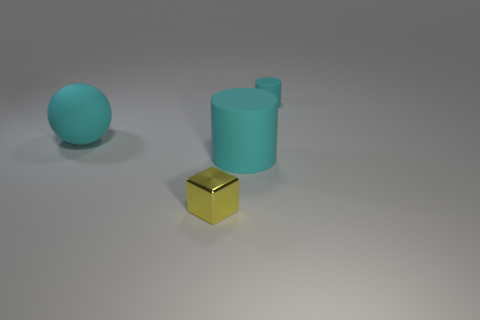Do the shiny thing and the cyan cylinder that is behind the large cyan sphere have the same size?
Your answer should be very brief. Yes. There is a cylinder to the left of the tiny cyan thing; what color is it?
Offer a very short reply. Cyan. What number of yellow things are matte balls or shiny blocks?
Offer a very short reply. 1. What color is the large matte cylinder?
Keep it short and to the point. Cyan. Is there any other thing that is made of the same material as the yellow cube?
Your answer should be very brief. No. Is the number of big things that are in front of the matte ball less than the number of small metal things that are left of the tiny yellow shiny thing?
Offer a very short reply. No. There is a thing that is both behind the large cylinder and right of the small block; what shape is it?
Your answer should be very brief. Cylinder. What number of yellow metal objects are the same shape as the small cyan matte thing?
Your answer should be very brief. 0. There is a ball that is the same material as the small cyan cylinder; what is its size?
Your response must be concise. Large. What number of purple shiny cylinders have the same size as the yellow metal object?
Provide a succinct answer. 0. 